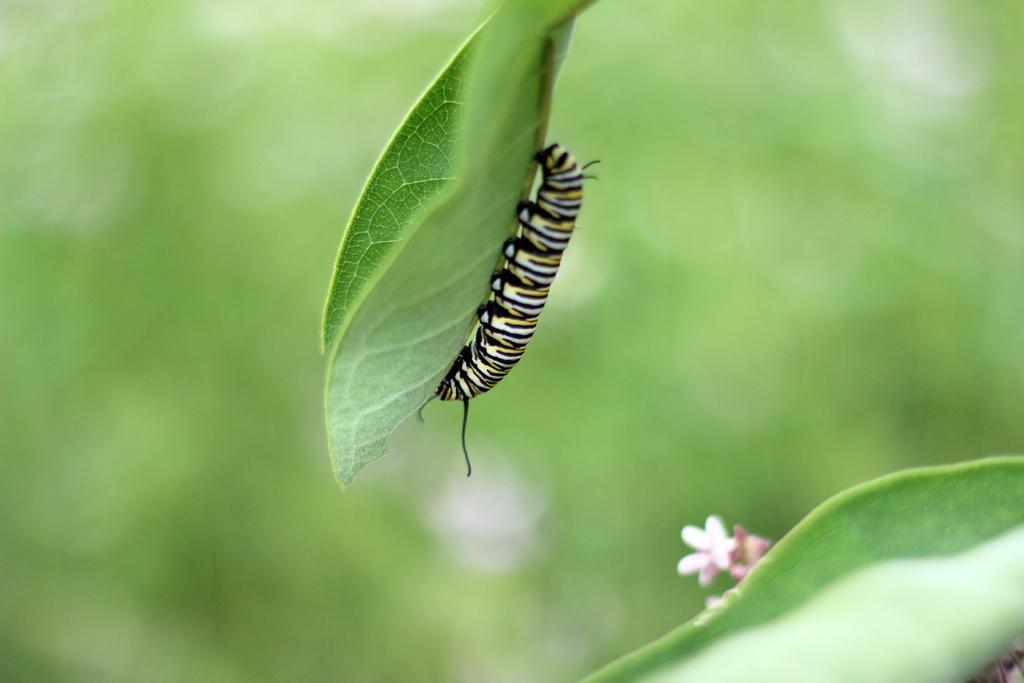Can you describe this image briefly? In the image there is a leaf with black, white and yellow color caterpillar on it. At the bottom of the image there is a leaf and pink flower. There is a green color background. 